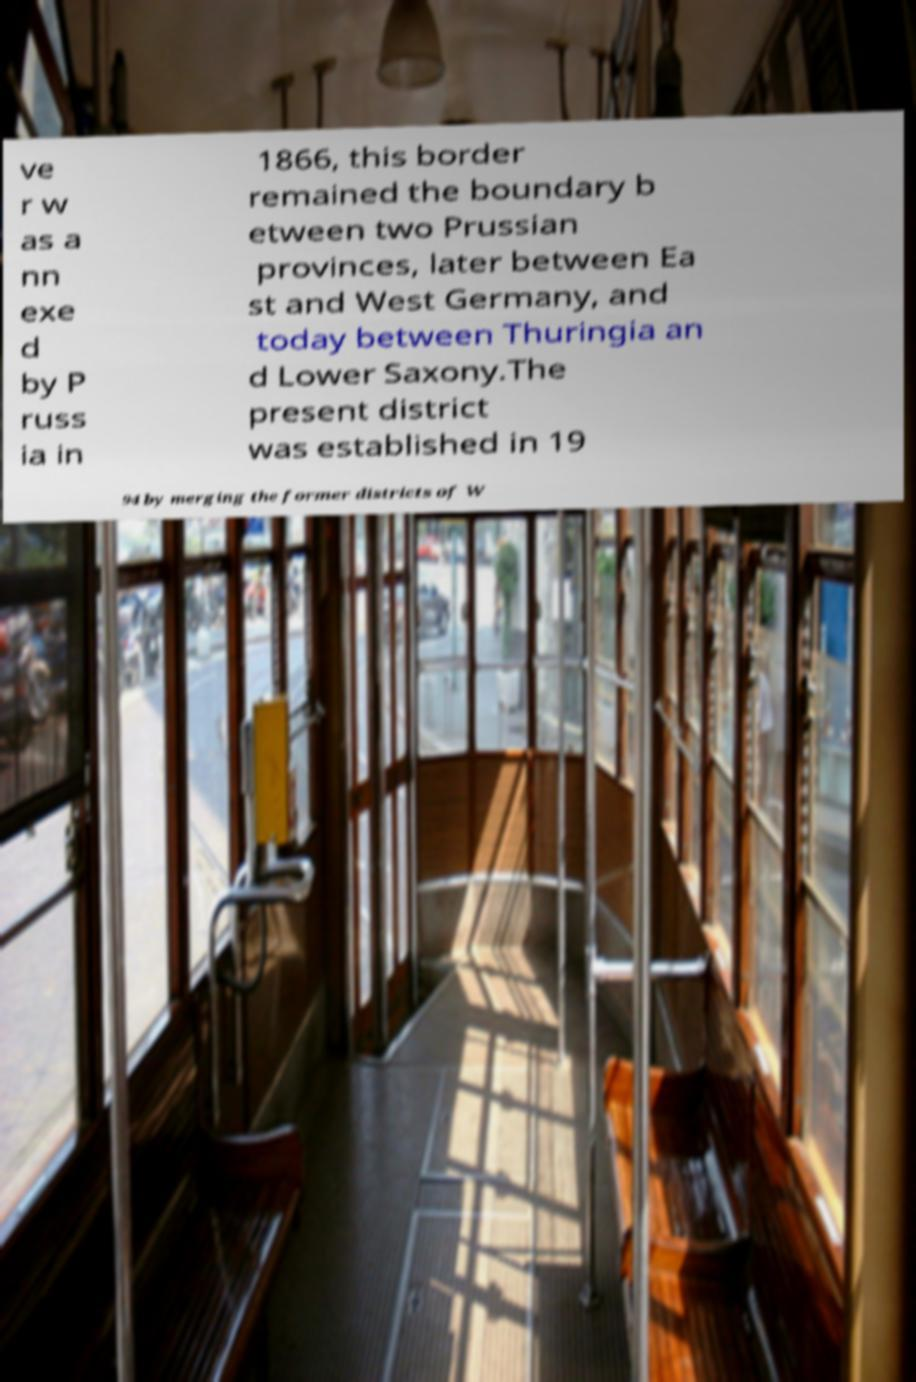Please identify and transcribe the text found in this image. ve r w as a nn exe d by P russ ia in 1866, this border remained the boundary b etween two Prussian provinces, later between Ea st and West Germany, and today between Thuringia an d Lower Saxony.The present district was established in 19 94 by merging the former districts of W 